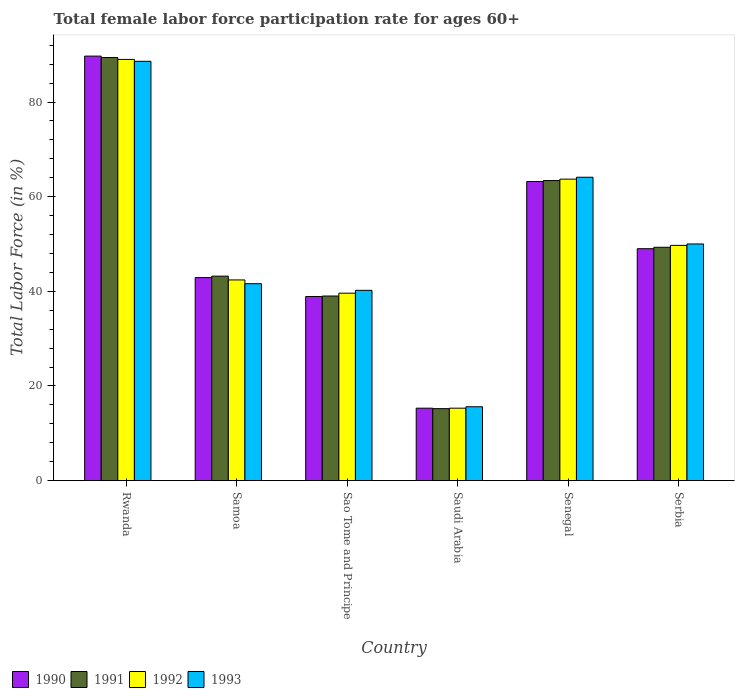Are the number of bars per tick equal to the number of legend labels?
Provide a succinct answer. Yes. Are the number of bars on each tick of the X-axis equal?
Provide a short and direct response. Yes. How many bars are there on the 3rd tick from the right?
Your response must be concise. 4. What is the label of the 6th group of bars from the left?
Your answer should be very brief. Serbia. What is the female labor force participation rate in 1993 in Sao Tome and Principe?
Offer a very short reply. 40.2. Across all countries, what is the maximum female labor force participation rate in 1991?
Ensure brevity in your answer.  89.4. Across all countries, what is the minimum female labor force participation rate in 1993?
Your answer should be very brief. 15.6. In which country was the female labor force participation rate in 1992 maximum?
Give a very brief answer. Rwanda. In which country was the female labor force participation rate in 1991 minimum?
Offer a very short reply. Saudi Arabia. What is the total female labor force participation rate in 1990 in the graph?
Offer a terse response. 299. What is the difference between the female labor force participation rate in 1990 in Sao Tome and Principe and that in Senegal?
Give a very brief answer. -24.3. What is the difference between the female labor force participation rate in 1991 in Saudi Arabia and the female labor force participation rate in 1992 in Serbia?
Provide a short and direct response. -34.5. What is the average female labor force participation rate in 1992 per country?
Provide a short and direct response. 49.95. What is the difference between the female labor force participation rate of/in 1991 and female labor force participation rate of/in 1990 in Sao Tome and Principe?
Your answer should be compact. 0.1. In how many countries, is the female labor force participation rate in 1991 greater than 32 %?
Your answer should be very brief. 5. What is the ratio of the female labor force participation rate in 1990 in Rwanda to that in Samoa?
Keep it short and to the point. 2.09. Is the female labor force participation rate in 1993 in Saudi Arabia less than that in Senegal?
Provide a short and direct response. Yes. Is the difference between the female labor force participation rate in 1991 in Saudi Arabia and Serbia greater than the difference between the female labor force participation rate in 1990 in Saudi Arabia and Serbia?
Your answer should be very brief. No. What is the difference between the highest and the second highest female labor force participation rate in 1992?
Offer a very short reply. 39.3. What is the difference between the highest and the lowest female labor force participation rate in 1990?
Offer a terse response. 74.4. Is the sum of the female labor force participation rate in 1991 in Sao Tome and Principe and Saudi Arabia greater than the maximum female labor force participation rate in 1993 across all countries?
Offer a very short reply. No. What does the 2nd bar from the left in Serbia represents?
Make the answer very short. 1991. Is it the case that in every country, the sum of the female labor force participation rate in 1992 and female labor force participation rate in 1993 is greater than the female labor force participation rate in 1990?
Your answer should be very brief. Yes. What is the difference between two consecutive major ticks on the Y-axis?
Ensure brevity in your answer.  20. Are the values on the major ticks of Y-axis written in scientific E-notation?
Your response must be concise. No. Does the graph contain any zero values?
Keep it short and to the point. No. Where does the legend appear in the graph?
Ensure brevity in your answer.  Bottom left. How many legend labels are there?
Provide a short and direct response. 4. What is the title of the graph?
Offer a very short reply. Total female labor force participation rate for ages 60+. Does "1983" appear as one of the legend labels in the graph?
Ensure brevity in your answer.  No. What is the label or title of the Y-axis?
Offer a terse response. Total Labor Force (in %). What is the Total Labor Force (in %) in 1990 in Rwanda?
Provide a succinct answer. 89.7. What is the Total Labor Force (in %) in 1991 in Rwanda?
Give a very brief answer. 89.4. What is the Total Labor Force (in %) in 1992 in Rwanda?
Give a very brief answer. 89. What is the Total Labor Force (in %) of 1993 in Rwanda?
Your answer should be compact. 88.6. What is the Total Labor Force (in %) in 1990 in Samoa?
Ensure brevity in your answer.  42.9. What is the Total Labor Force (in %) in 1991 in Samoa?
Provide a succinct answer. 43.2. What is the Total Labor Force (in %) of 1992 in Samoa?
Give a very brief answer. 42.4. What is the Total Labor Force (in %) of 1993 in Samoa?
Offer a terse response. 41.6. What is the Total Labor Force (in %) of 1990 in Sao Tome and Principe?
Provide a succinct answer. 38.9. What is the Total Labor Force (in %) of 1991 in Sao Tome and Principe?
Offer a terse response. 39. What is the Total Labor Force (in %) of 1992 in Sao Tome and Principe?
Give a very brief answer. 39.6. What is the Total Labor Force (in %) of 1993 in Sao Tome and Principe?
Give a very brief answer. 40.2. What is the Total Labor Force (in %) of 1990 in Saudi Arabia?
Your answer should be compact. 15.3. What is the Total Labor Force (in %) in 1991 in Saudi Arabia?
Your response must be concise. 15.2. What is the Total Labor Force (in %) of 1992 in Saudi Arabia?
Offer a terse response. 15.3. What is the Total Labor Force (in %) in 1993 in Saudi Arabia?
Offer a terse response. 15.6. What is the Total Labor Force (in %) in 1990 in Senegal?
Your response must be concise. 63.2. What is the Total Labor Force (in %) of 1991 in Senegal?
Ensure brevity in your answer.  63.4. What is the Total Labor Force (in %) in 1992 in Senegal?
Your answer should be very brief. 63.7. What is the Total Labor Force (in %) of 1993 in Senegal?
Your answer should be compact. 64.1. What is the Total Labor Force (in %) of 1990 in Serbia?
Your answer should be compact. 49. What is the Total Labor Force (in %) in 1991 in Serbia?
Give a very brief answer. 49.3. What is the Total Labor Force (in %) of 1992 in Serbia?
Your answer should be very brief. 49.7. Across all countries, what is the maximum Total Labor Force (in %) in 1990?
Offer a very short reply. 89.7. Across all countries, what is the maximum Total Labor Force (in %) in 1991?
Make the answer very short. 89.4. Across all countries, what is the maximum Total Labor Force (in %) of 1992?
Provide a short and direct response. 89. Across all countries, what is the maximum Total Labor Force (in %) of 1993?
Offer a terse response. 88.6. Across all countries, what is the minimum Total Labor Force (in %) of 1990?
Keep it short and to the point. 15.3. Across all countries, what is the minimum Total Labor Force (in %) in 1991?
Offer a very short reply. 15.2. Across all countries, what is the minimum Total Labor Force (in %) of 1992?
Ensure brevity in your answer.  15.3. Across all countries, what is the minimum Total Labor Force (in %) of 1993?
Offer a very short reply. 15.6. What is the total Total Labor Force (in %) of 1990 in the graph?
Make the answer very short. 299. What is the total Total Labor Force (in %) in 1991 in the graph?
Ensure brevity in your answer.  299.5. What is the total Total Labor Force (in %) of 1992 in the graph?
Provide a succinct answer. 299.7. What is the total Total Labor Force (in %) of 1993 in the graph?
Provide a succinct answer. 300.1. What is the difference between the Total Labor Force (in %) in 1990 in Rwanda and that in Samoa?
Provide a succinct answer. 46.8. What is the difference between the Total Labor Force (in %) in 1991 in Rwanda and that in Samoa?
Provide a short and direct response. 46.2. What is the difference between the Total Labor Force (in %) in 1992 in Rwanda and that in Samoa?
Your answer should be very brief. 46.6. What is the difference between the Total Labor Force (in %) in 1990 in Rwanda and that in Sao Tome and Principe?
Provide a short and direct response. 50.8. What is the difference between the Total Labor Force (in %) in 1991 in Rwanda and that in Sao Tome and Principe?
Your answer should be very brief. 50.4. What is the difference between the Total Labor Force (in %) of 1992 in Rwanda and that in Sao Tome and Principe?
Your response must be concise. 49.4. What is the difference between the Total Labor Force (in %) in 1993 in Rwanda and that in Sao Tome and Principe?
Your answer should be compact. 48.4. What is the difference between the Total Labor Force (in %) in 1990 in Rwanda and that in Saudi Arabia?
Provide a short and direct response. 74.4. What is the difference between the Total Labor Force (in %) in 1991 in Rwanda and that in Saudi Arabia?
Offer a very short reply. 74.2. What is the difference between the Total Labor Force (in %) of 1992 in Rwanda and that in Saudi Arabia?
Offer a terse response. 73.7. What is the difference between the Total Labor Force (in %) of 1991 in Rwanda and that in Senegal?
Ensure brevity in your answer.  26. What is the difference between the Total Labor Force (in %) in 1992 in Rwanda and that in Senegal?
Your answer should be compact. 25.3. What is the difference between the Total Labor Force (in %) in 1990 in Rwanda and that in Serbia?
Provide a succinct answer. 40.7. What is the difference between the Total Labor Force (in %) of 1991 in Rwanda and that in Serbia?
Your response must be concise. 40.1. What is the difference between the Total Labor Force (in %) in 1992 in Rwanda and that in Serbia?
Keep it short and to the point. 39.3. What is the difference between the Total Labor Force (in %) in 1993 in Rwanda and that in Serbia?
Provide a succinct answer. 38.6. What is the difference between the Total Labor Force (in %) in 1991 in Samoa and that in Sao Tome and Principe?
Provide a short and direct response. 4.2. What is the difference between the Total Labor Force (in %) of 1990 in Samoa and that in Saudi Arabia?
Provide a short and direct response. 27.6. What is the difference between the Total Labor Force (in %) in 1991 in Samoa and that in Saudi Arabia?
Your answer should be very brief. 28. What is the difference between the Total Labor Force (in %) in 1992 in Samoa and that in Saudi Arabia?
Make the answer very short. 27.1. What is the difference between the Total Labor Force (in %) in 1993 in Samoa and that in Saudi Arabia?
Ensure brevity in your answer.  26. What is the difference between the Total Labor Force (in %) in 1990 in Samoa and that in Senegal?
Make the answer very short. -20.3. What is the difference between the Total Labor Force (in %) of 1991 in Samoa and that in Senegal?
Provide a succinct answer. -20.2. What is the difference between the Total Labor Force (in %) of 1992 in Samoa and that in Senegal?
Your answer should be very brief. -21.3. What is the difference between the Total Labor Force (in %) of 1993 in Samoa and that in Senegal?
Offer a terse response. -22.5. What is the difference between the Total Labor Force (in %) in 1992 in Samoa and that in Serbia?
Provide a short and direct response. -7.3. What is the difference between the Total Labor Force (in %) of 1990 in Sao Tome and Principe and that in Saudi Arabia?
Your answer should be compact. 23.6. What is the difference between the Total Labor Force (in %) of 1991 in Sao Tome and Principe and that in Saudi Arabia?
Give a very brief answer. 23.8. What is the difference between the Total Labor Force (in %) of 1992 in Sao Tome and Principe and that in Saudi Arabia?
Your answer should be compact. 24.3. What is the difference between the Total Labor Force (in %) of 1993 in Sao Tome and Principe and that in Saudi Arabia?
Your answer should be compact. 24.6. What is the difference between the Total Labor Force (in %) in 1990 in Sao Tome and Principe and that in Senegal?
Offer a very short reply. -24.3. What is the difference between the Total Labor Force (in %) in 1991 in Sao Tome and Principe and that in Senegal?
Keep it short and to the point. -24.4. What is the difference between the Total Labor Force (in %) of 1992 in Sao Tome and Principe and that in Senegal?
Provide a succinct answer. -24.1. What is the difference between the Total Labor Force (in %) of 1993 in Sao Tome and Principe and that in Senegal?
Your answer should be compact. -23.9. What is the difference between the Total Labor Force (in %) of 1990 in Sao Tome and Principe and that in Serbia?
Give a very brief answer. -10.1. What is the difference between the Total Labor Force (in %) in 1990 in Saudi Arabia and that in Senegal?
Your answer should be compact. -47.9. What is the difference between the Total Labor Force (in %) in 1991 in Saudi Arabia and that in Senegal?
Offer a terse response. -48.2. What is the difference between the Total Labor Force (in %) in 1992 in Saudi Arabia and that in Senegal?
Your response must be concise. -48.4. What is the difference between the Total Labor Force (in %) in 1993 in Saudi Arabia and that in Senegal?
Ensure brevity in your answer.  -48.5. What is the difference between the Total Labor Force (in %) of 1990 in Saudi Arabia and that in Serbia?
Provide a succinct answer. -33.7. What is the difference between the Total Labor Force (in %) in 1991 in Saudi Arabia and that in Serbia?
Provide a short and direct response. -34.1. What is the difference between the Total Labor Force (in %) of 1992 in Saudi Arabia and that in Serbia?
Your answer should be compact. -34.4. What is the difference between the Total Labor Force (in %) in 1993 in Saudi Arabia and that in Serbia?
Provide a short and direct response. -34.4. What is the difference between the Total Labor Force (in %) in 1992 in Senegal and that in Serbia?
Your answer should be compact. 14. What is the difference between the Total Labor Force (in %) in 1990 in Rwanda and the Total Labor Force (in %) in 1991 in Samoa?
Give a very brief answer. 46.5. What is the difference between the Total Labor Force (in %) of 1990 in Rwanda and the Total Labor Force (in %) of 1992 in Samoa?
Ensure brevity in your answer.  47.3. What is the difference between the Total Labor Force (in %) in 1990 in Rwanda and the Total Labor Force (in %) in 1993 in Samoa?
Your answer should be compact. 48.1. What is the difference between the Total Labor Force (in %) of 1991 in Rwanda and the Total Labor Force (in %) of 1993 in Samoa?
Keep it short and to the point. 47.8. What is the difference between the Total Labor Force (in %) of 1992 in Rwanda and the Total Labor Force (in %) of 1993 in Samoa?
Your response must be concise. 47.4. What is the difference between the Total Labor Force (in %) of 1990 in Rwanda and the Total Labor Force (in %) of 1991 in Sao Tome and Principe?
Your answer should be very brief. 50.7. What is the difference between the Total Labor Force (in %) of 1990 in Rwanda and the Total Labor Force (in %) of 1992 in Sao Tome and Principe?
Offer a terse response. 50.1. What is the difference between the Total Labor Force (in %) of 1990 in Rwanda and the Total Labor Force (in %) of 1993 in Sao Tome and Principe?
Provide a succinct answer. 49.5. What is the difference between the Total Labor Force (in %) of 1991 in Rwanda and the Total Labor Force (in %) of 1992 in Sao Tome and Principe?
Offer a very short reply. 49.8. What is the difference between the Total Labor Force (in %) in 1991 in Rwanda and the Total Labor Force (in %) in 1993 in Sao Tome and Principe?
Your answer should be compact. 49.2. What is the difference between the Total Labor Force (in %) of 1992 in Rwanda and the Total Labor Force (in %) of 1993 in Sao Tome and Principe?
Keep it short and to the point. 48.8. What is the difference between the Total Labor Force (in %) in 1990 in Rwanda and the Total Labor Force (in %) in 1991 in Saudi Arabia?
Give a very brief answer. 74.5. What is the difference between the Total Labor Force (in %) in 1990 in Rwanda and the Total Labor Force (in %) in 1992 in Saudi Arabia?
Offer a very short reply. 74.4. What is the difference between the Total Labor Force (in %) of 1990 in Rwanda and the Total Labor Force (in %) of 1993 in Saudi Arabia?
Your answer should be compact. 74.1. What is the difference between the Total Labor Force (in %) of 1991 in Rwanda and the Total Labor Force (in %) of 1992 in Saudi Arabia?
Offer a terse response. 74.1. What is the difference between the Total Labor Force (in %) of 1991 in Rwanda and the Total Labor Force (in %) of 1993 in Saudi Arabia?
Offer a terse response. 73.8. What is the difference between the Total Labor Force (in %) of 1992 in Rwanda and the Total Labor Force (in %) of 1993 in Saudi Arabia?
Your answer should be compact. 73.4. What is the difference between the Total Labor Force (in %) of 1990 in Rwanda and the Total Labor Force (in %) of 1991 in Senegal?
Offer a very short reply. 26.3. What is the difference between the Total Labor Force (in %) in 1990 in Rwanda and the Total Labor Force (in %) in 1992 in Senegal?
Give a very brief answer. 26. What is the difference between the Total Labor Force (in %) in 1990 in Rwanda and the Total Labor Force (in %) in 1993 in Senegal?
Give a very brief answer. 25.6. What is the difference between the Total Labor Force (in %) in 1991 in Rwanda and the Total Labor Force (in %) in 1992 in Senegal?
Make the answer very short. 25.7. What is the difference between the Total Labor Force (in %) of 1991 in Rwanda and the Total Labor Force (in %) of 1993 in Senegal?
Offer a very short reply. 25.3. What is the difference between the Total Labor Force (in %) of 1992 in Rwanda and the Total Labor Force (in %) of 1993 in Senegal?
Keep it short and to the point. 24.9. What is the difference between the Total Labor Force (in %) of 1990 in Rwanda and the Total Labor Force (in %) of 1991 in Serbia?
Offer a very short reply. 40.4. What is the difference between the Total Labor Force (in %) in 1990 in Rwanda and the Total Labor Force (in %) in 1992 in Serbia?
Offer a terse response. 40. What is the difference between the Total Labor Force (in %) of 1990 in Rwanda and the Total Labor Force (in %) of 1993 in Serbia?
Keep it short and to the point. 39.7. What is the difference between the Total Labor Force (in %) in 1991 in Rwanda and the Total Labor Force (in %) in 1992 in Serbia?
Keep it short and to the point. 39.7. What is the difference between the Total Labor Force (in %) in 1991 in Rwanda and the Total Labor Force (in %) in 1993 in Serbia?
Provide a succinct answer. 39.4. What is the difference between the Total Labor Force (in %) in 1992 in Rwanda and the Total Labor Force (in %) in 1993 in Serbia?
Your answer should be compact. 39. What is the difference between the Total Labor Force (in %) of 1990 in Samoa and the Total Labor Force (in %) of 1991 in Sao Tome and Principe?
Ensure brevity in your answer.  3.9. What is the difference between the Total Labor Force (in %) of 1990 in Samoa and the Total Labor Force (in %) of 1992 in Sao Tome and Principe?
Ensure brevity in your answer.  3.3. What is the difference between the Total Labor Force (in %) in 1991 in Samoa and the Total Labor Force (in %) in 1992 in Sao Tome and Principe?
Give a very brief answer. 3.6. What is the difference between the Total Labor Force (in %) of 1991 in Samoa and the Total Labor Force (in %) of 1993 in Sao Tome and Principe?
Ensure brevity in your answer.  3. What is the difference between the Total Labor Force (in %) in 1990 in Samoa and the Total Labor Force (in %) in 1991 in Saudi Arabia?
Provide a succinct answer. 27.7. What is the difference between the Total Labor Force (in %) of 1990 in Samoa and the Total Labor Force (in %) of 1992 in Saudi Arabia?
Make the answer very short. 27.6. What is the difference between the Total Labor Force (in %) in 1990 in Samoa and the Total Labor Force (in %) in 1993 in Saudi Arabia?
Make the answer very short. 27.3. What is the difference between the Total Labor Force (in %) in 1991 in Samoa and the Total Labor Force (in %) in 1992 in Saudi Arabia?
Offer a terse response. 27.9. What is the difference between the Total Labor Force (in %) in 1991 in Samoa and the Total Labor Force (in %) in 1993 in Saudi Arabia?
Offer a terse response. 27.6. What is the difference between the Total Labor Force (in %) of 1992 in Samoa and the Total Labor Force (in %) of 1993 in Saudi Arabia?
Offer a terse response. 26.8. What is the difference between the Total Labor Force (in %) in 1990 in Samoa and the Total Labor Force (in %) in 1991 in Senegal?
Make the answer very short. -20.5. What is the difference between the Total Labor Force (in %) of 1990 in Samoa and the Total Labor Force (in %) of 1992 in Senegal?
Your answer should be compact. -20.8. What is the difference between the Total Labor Force (in %) in 1990 in Samoa and the Total Labor Force (in %) in 1993 in Senegal?
Provide a succinct answer. -21.2. What is the difference between the Total Labor Force (in %) in 1991 in Samoa and the Total Labor Force (in %) in 1992 in Senegal?
Your response must be concise. -20.5. What is the difference between the Total Labor Force (in %) of 1991 in Samoa and the Total Labor Force (in %) of 1993 in Senegal?
Offer a very short reply. -20.9. What is the difference between the Total Labor Force (in %) of 1992 in Samoa and the Total Labor Force (in %) of 1993 in Senegal?
Give a very brief answer. -21.7. What is the difference between the Total Labor Force (in %) in 1990 in Samoa and the Total Labor Force (in %) in 1991 in Serbia?
Your answer should be compact. -6.4. What is the difference between the Total Labor Force (in %) of 1990 in Samoa and the Total Labor Force (in %) of 1992 in Serbia?
Your response must be concise. -6.8. What is the difference between the Total Labor Force (in %) in 1990 in Samoa and the Total Labor Force (in %) in 1993 in Serbia?
Provide a succinct answer. -7.1. What is the difference between the Total Labor Force (in %) of 1990 in Sao Tome and Principe and the Total Labor Force (in %) of 1991 in Saudi Arabia?
Your answer should be compact. 23.7. What is the difference between the Total Labor Force (in %) of 1990 in Sao Tome and Principe and the Total Labor Force (in %) of 1992 in Saudi Arabia?
Offer a terse response. 23.6. What is the difference between the Total Labor Force (in %) of 1990 in Sao Tome and Principe and the Total Labor Force (in %) of 1993 in Saudi Arabia?
Provide a short and direct response. 23.3. What is the difference between the Total Labor Force (in %) of 1991 in Sao Tome and Principe and the Total Labor Force (in %) of 1992 in Saudi Arabia?
Give a very brief answer. 23.7. What is the difference between the Total Labor Force (in %) of 1991 in Sao Tome and Principe and the Total Labor Force (in %) of 1993 in Saudi Arabia?
Offer a terse response. 23.4. What is the difference between the Total Labor Force (in %) of 1990 in Sao Tome and Principe and the Total Labor Force (in %) of 1991 in Senegal?
Keep it short and to the point. -24.5. What is the difference between the Total Labor Force (in %) of 1990 in Sao Tome and Principe and the Total Labor Force (in %) of 1992 in Senegal?
Provide a short and direct response. -24.8. What is the difference between the Total Labor Force (in %) in 1990 in Sao Tome and Principe and the Total Labor Force (in %) in 1993 in Senegal?
Provide a succinct answer. -25.2. What is the difference between the Total Labor Force (in %) of 1991 in Sao Tome and Principe and the Total Labor Force (in %) of 1992 in Senegal?
Your response must be concise. -24.7. What is the difference between the Total Labor Force (in %) of 1991 in Sao Tome and Principe and the Total Labor Force (in %) of 1993 in Senegal?
Provide a short and direct response. -25.1. What is the difference between the Total Labor Force (in %) in 1992 in Sao Tome and Principe and the Total Labor Force (in %) in 1993 in Senegal?
Offer a very short reply. -24.5. What is the difference between the Total Labor Force (in %) of 1990 in Sao Tome and Principe and the Total Labor Force (in %) of 1991 in Serbia?
Give a very brief answer. -10.4. What is the difference between the Total Labor Force (in %) of 1990 in Sao Tome and Principe and the Total Labor Force (in %) of 1992 in Serbia?
Ensure brevity in your answer.  -10.8. What is the difference between the Total Labor Force (in %) of 1990 in Sao Tome and Principe and the Total Labor Force (in %) of 1993 in Serbia?
Offer a terse response. -11.1. What is the difference between the Total Labor Force (in %) of 1991 in Sao Tome and Principe and the Total Labor Force (in %) of 1993 in Serbia?
Offer a very short reply. -11. What is the difference between the Total Labor Force (in %) of 1992 in Sao Tome and Principe and the Total Labor Force (in %) of 1993 in Serbia?
Ensure brevity in your answer.  -10.4. What is the difference between the Total Labor Force (in %) of 1990 in Saudi Arabia and the Total Labor Force (in %) of 1991 in Senegal?
Your response must be concise. -48.1. What is the difference between the Total Labor Force (in %) in 1990 in Saudi Arabia and the Total Labor Force (in %) in 1992 in Senegal?
Offer a terse response. -48.4. What is the difference between the Total Labor Force (in %) of 1990 in Saudi Arabia and the Total Labor Force (in %) of 1993 in Senegal?
Your answer should be very brief. -48.8. What is the difference between the Total Labor Force (in %) in 1991 in Saudi Arabia and the Total Labor Force (in %) in 1992 in Senegal?
Provide a succinct answer. -48.5. What is the difference between the Total Labor Force (in %) of 1991 in Saudi Arabia and the Total Labor Force (in %) of 1993 in Senegal?
Your answer should be very brief. -48.9. What is the difference between the Total Labor Force (in %) in 1992 in Saudi Arabia and the Total Labor Force (in %) in 1993 in Senegal?
Offer a terse response. -48.8. What is the difference between the Total Labor Force (in %) of 1990 in Saudi Arabia and the Total Labor Force (in %) of 1991 in Serbia?
Keep it short and to the point. -34. What is the difference between the Total Labor Force (in %) of 1990 in Saudi Arabia and the Total Labor Force (in %) of 1992 in Serbia?
Your answer should be very brief. -34.4. What is the difference between the Total Labor Force (in %) of 1990 in Saudi Arabia and the Total Labor Force (in %) of 1993 in Serbia?
Your response must be concise. -34.7. What is the difference between the Total Labor Force (in %) in 1991 in Saudi Arabia and the Total Labor Force (in %) in 1992 in Serbia?
Give a very brief answer. -34.5. What is the difference between the Total Labor Force (in %) of 1991 in Saudi Arabia and the Total Labor Force (in %) of 1993 in Serbia?
Give a very brief answer. -34.8. What is the difference between the Total Labor Force (in %) of 1992 in Saudi Arabia and the Total Labor Force (in %) of 1993 in Serbia?
Make the answer very short. -34.7. What is the difference between the Total Labor Force (in %) in 1990 in Senegal and the Total Labor Force (in %) in 1991 in Serbia?
Offer a very short reply. 13.9. What is the difference between the Total Labor Force (in %) of 1991 in Senegal and the Total Labor Force (in %) of 1993 in Serbia?
Offer a terse response. 13.4. What is the difference between the Total Labor Force (in %) of 1992 in Senegal and the Total Labor Force (in %) of 1993 in Serbia?
Provide a succinct answer. 13.7. What is the average Total Labor Force (in %) of 1990 per country?
Offer a very short reply. 49.83. What is the average Total Labor Force (in %) in 1991 per country?
Offer a very short reply. 49.92. What is the average Total Labor Force (in %) of 1992 per country?
Provide a short and direct response. 49.95. What is the average Total Labor Force (in %) in 1993 per country?
Ensure brevity in your answer.  50.02. What is the difference between the Total Labor Force (in %) of 1990 and Total Labor Force (in %) of 1992 in Rwanda?
Offer a very short reply. 0.7. What is the difference between the Total Labor Force (in %) in 1991 and Total Labor Force (in %) in 1992 in Rwanda?
Make the answer very short. 0.4. What is the difference between the Total Labor Force (in %) of 1991 and Total Labor Force (in %) of 1993 in Rwanda?
Provide a short and direct response. 0.8. What is the difference between the Total Labor Force (in %) in 1990 and Total Labor Force (in %) in 1991 in Samoa?
Provide a short and direct response. -0.3. What is the difference between the Total Labor Force (in %) in 1990 and Total Labor Force (in %) in 1992 in Samoa?
Your response must be concise. 0.5. What is the difference between the Total Labor Force (in %) of 1990 and Total Labor Force (in %) of 1993 in Samoa?
Your response must be concise. 1.3. What is the difference between the Total Labor Force (in %) of 1991 and Total Labor Force (in %) of 1992 in Samoa?
Your response must be concise. 0.8. What is the difference between the Total Labor Force (in %) of 1991 and Total Labor Force (in %) of 1993 in Samoa?
Your answer should be very brief. 1.6. What is the difference between the Total Labor Force (in %) of 1990 and Total Labor Force (in %) of 1991 in Sao Tome and Principe?
Provide a short and direct response. -0.1. What is the difference between the Total Labor Force (in %) in 1990 and Total Labor Force (in %) in 1992 in Sao Tome and Principe?
Provide a succinct answer. -0.7. What is the difference between the Total Labor Force (in %) in 1991 and Total Labor Force (in %) in 1992 in Sao Tome and Principe?
Give a very brief answer. -0.6. What is the difference between the Total Labor Force (in %) of 1991 and Total Labor Force (in %) of 1993 in Sao Tome and Principe?
Your answer should be compact. -1.2. What is the difference between the Total Labor Force (in %) in 1992 and Total Labor Force (in %) in 1993 in Sao Tome and Principe?
Provide a succinct answer. -0.6. What is the difference between the Total Labor Force (in %) in 1990 and Total Labor Force (in %) in 1991 in Saudi Arabia?
Your answer should be very brief. 0.1. What is the difference between the Total Labor Force (in %) in 1990 and Total Labor Force (in %) in 1992 in Saudi Arabia?
Offer a terse response. 0. What is the difference between the Total Labor Force (in %) of 1990 and Total Labor Force (in %) of 1993 in Saudi Arabia?
Your response must be concise. -0.3. What is the difference between the Total Labor Force (in %) in 1990 and Total Labor Force (in %) in 1992 in Senegal?
Make the answer very short. -0.5. What is the difference between the Total Labor Force (in %) in 1990 and Total Labor Force (in %) in 1993 in Senegal?
Keep it short and to the point. -0.9. What is the difference between the Total Labor Force (in %) in 1991 and Total Labor Force (in %) in 1992 in Senegal?
Provide a succinct answer. -0.3. What is the difference between the Total Labor Force (in %) in 1990 and Total Labor Force (in %) in 1991 in Serbia?
Your answer should be very brief. -0.3. What is the difference between the Total Labor Force (in %) of 1990 and Total Labor Force (in %) of 1992 in Serbia?
Your response must be concise. -0.7. What is the difference between the Total Labor Force (in %) of 1990 and Total Labor Force (in %) of 1993 in Serbia?
Your answer should be compact. -1. What is the difference between the Total Labor Force (in %) of 1991 and Total Labor Force (in %) of 1992 in Serbia?
Give a very brief answer. -0.4. What is the difference between the Total Labor Force (in %) in 1991 and Total Labor Force (in %) in 1993 in Serbia?
Provide a succinct answer. -0.7. What is the ratio of the Total Labor Force (in %) of 1990 in Rwanda to that in Samoa?
Provide a short and direct response. 2.09. What is the ratio of the Total Labor Force (in %) in 1991 in Rwanda to that in Samoa?
Give a very brief answer. 2.07. What is the ratio of the Total Labor Force (in %) in 1992 in Rwanda to that in Samoa?
Keep it short and to the point. 2.1. What is the ratio of the Total Labor Force (in %) in 1993 in Rwanda to that in Samoa?
Provide a succinct answer. 2.13. What is the ratio of the Total Labor Force (in %) of 1990 in Rwanda to that in Sao Tome and Principe?
Keep it short and to the point. 2.31. What is the ratio of the Total Labor Force (in %) in 1991 in Rwanda to that in Sao Tome and Principe?
Your response must be concise. 2.29. What is the ratio of the Total Labor Force (in %) of 1992 in Rwanda to that in Sao Tome and Principe?
Offer a very short reply. 2.25. What is the ratio of the Total Labor Force (in %) in 1993 in Rwanda to that in Sao Tome and Principe?
Your answer should be compact. 2.2. What is the ratio of the Total Labor Force (in %) in 1990 in Rwanda to that in Saudi Arabia?
Make the answer very short. 5.86. What is the ratio of the Total Labor Force (in %) in 1991 in Rwanda to that in Saudi Arabia?
Keep it short and to the point. 5.88. What is the ratio of the Total Labor Force (in %) in 1992 in Rwanda to that in Saudi Arabia?
Make the answer very short. 5.82. What is the ratio of the Total Labor Force (in %) in 1993 in Rwanda to that in Saudi Arabia?
Provide a succinct answer. 5.68. What is the ratio of the Total Labor Force (in %) in 1990 in Rwanda to that in Senegal?
Your answer should be very brief. 1.42. What is the ratio of the Total Labor Force (in %) in 1991 in Rwanda to that in Senegal?
Your answer should be very brief. 1.41. What is the ratio of the Total Labor Force (in %) of 1992 in Rwanda to that in Senegal?
Make the answer very short. 1.4. What is the ratio of the Total Labor Force (in %) in 1993 in Rwanda to that in Senegal?
Your answer should be compact. 1.38. What is the ratio of the Total Labor Force (in %) in 1990 in Rwanda to that in Serbia?
Offer a very short reply. 1.83. What is the ratio of the Total Labor Force (in %) of 1991 in Rwanda to that in Serbia?
Provide a succinct answer. 1.81. What is the ratio of the Total Labor Force (in %) of 1992 in Rwanda to that in Serbia?
Offer a terse response. 1.79. What is the ratio of the Total Labor Force (in %) of 1993 in Rwanda to that in Serbia?
Your answer should be very brief. 1.77. What is the ratio of the Total Labor Force (in %) of 1990 in Samoa to that in Sao Tome and Principe?
Ensure brevity in your answer.  1.1. What is the ratio of the Total Labor Force (in %) of 1991 in Samoa to that in Sao Tome and Principe?
Provide a short and direct response. 1.11. What is the ratio of the Total Labor Force (in %) in 1992 in Samoa to that in Sao Tome and Principe?
Keep it short and to the point. 1.07. What is the ratio of the Total Labor Force (in %) of 1993 in Samoa to that in Sao Tome and Principe?
Make the answer very short. 1.03. What is the ratio of the Total Labor Force (in %) of 1990 in Samoa to that in Saudi Arabia?
Offer a terse response. 2.8. What is the ratio of the Total Labor Force (in %) in 1991 in Samoa to that in Saudi Arabia?
Your answer should be compact. 2.84. What is the ratio of the Total Labor Force (in %) in 1992 in Samoa to that in Saudi Arabia?
Your answer should be very brief. 2.77. What is the ratio of the Total Labor Force (in %) in 1993 in Samoa to that in Saudi Arabia?
Make the answer very short. 2.67. What is the ratio of the Total Labor Force (in %) of 1990 in Samoa to that in Senegal?
Keep it short and to the point. 0.68. What is the ratio of the Total Labor Force (in %) of 1991 in Samoa to that in Senegal?
Offer a terse response. 0.68. What is the ratio of the Total Labor Force (in %) in 1992 in Samoa to that in Senegal?
Offer a terse response. 0.67. What is the ratio of the Total Labor Force (in %) in 1993 in Samoa to that in Senegal?
Keep it short and to the point. 0.65. What is the ratio of the Total Labor Force (in %) of 1990 in Samoa to that in Serbia?
Make the answer very short. 0.88. What is the ratio of the Total Labor Force (in %) in 1991 in Samoa to that in Serbia?
Provide a succinct answer. 0.88. What is the ratio of the Total Labor Force (in %) in 1992 in Samoa to that in Serbia?
Ensure brevity in your answer.  0.85. What is the ratio of the Total Labor Force (in %) in 1993 in Samoa to that in Serbia?
Make the answer very short. 0.83. What is the ratio of the Total Labor Force (in %) of 1990 in Sao Tome and Principe to that in Saudi Arabia?
Your answer should be very brief. 2.54. What is the ratio of the Total Labor Force (in %) of 1991 in Sao Tome and Principe to that in Saudi Arabia?
Your answer should be very brief. 2.57. What is the ratio of the Total Labor Force (in %) in 1992 in Sao Tome and Principe to that in Saudi Arabia?
Your response must be concise. 2.59. What is the ratio of the Total Labor Force (in %) in 1993 in Sao Tome and Principe to that in Saudi Arabia?
Your answer should be compact. 2.58. What is the ratio of the Total Labor Force (in %) of 1990 in Sao Tome and Principe to that in Senegal?
Offer a terse response. 0.62. What is the ratio of the Total Labor Force (in %) of 1991 in Sao Tome and Principe to that in Senegal?
Offer a terse response. 0.62. What is the ratio of the Total Labor Force (in %) in 1992 in Sao Tome and Principe to that in Senegal?
Offer a terse response. 0.62. What is the ratio of the Total Labor Force (in %) of 1993 in Sao Tome and Principe to that in Senegal?
Ensure brevity in your answer.  0.63. What is the ratio of the Total Labor Force (in %) in 1990 in Sao Tome and Principe to that in Serbia?
Make the answer very short. 0.79. What is the ratio of the Total Labor Force (in %) of 1991 in Sao Tome and Principe to that in Serbia?
Your answer should be compact. 0.79. What is the ratio of the Total Labor Force (in %) in 1992 in Sao Tome and Principe to that in Serbia?
Your answer should be very brief. 0.8. What is the ratio of the Total Labor Force (in %) in 1993 in Sao Tome and Principe to that in Serbia?
Your response must be concise. 0.8. What is the ratio of the Total Labor Force (in %) of 1990 in Saudi Arabia to that in Senegal?
Ensure brevity in your answer.  0.24. What is the ratio of the Total Labor Force (in %) of 1991 in Saudi Arabia to that in Senegal?
Make the answer very short. 0.24. What is the ratio of the Total Labor Force (in %) in 1992 in Saudi Arabia to that in Senegal?
Your response must be concise. 0.24. What is the ratio of the Total Labor Force (in %) in 1993 in Saudi Arabia to that in Senegal?
Provide a short and direct response. 0.24. What is the ratio of the Total Labor Force (in %) of 1990 in Saudi Arabia to that in Serbia?
Your response must be concise. 0.31. What is the ratio of the Total Labor Force (in %) in 1991 in Saudi Arabia to that in Serbia?
Your answer should be compact. 0.31. What is the ratio of the Total Labor Force (in %) in 1992 in Saudi Arabia to that in Serbia?
Keep it short and to the point. 0.31. What is the ratio of the Total Labor Force (in %) of 1993 in Saudi Arabia to that in Serbia?
Your answer should be very brief. 0.31. What is the ratio of the Total Labor Force (in %) of 1990 in Senegal to that in Serbia?
Provide a succinct answer. 1.29. What is the ratio of the Total Labor Force (in %) of 1991 in Senegal to that in Serbia?
Your response must be concise. 1.29. What is the ratio of the Total Labor Force (in %) of 1992 in Senegal to that in Serbia?
Make the answer very short. 1.28. What is the ratio of the Total Labor Force (in %) in 1993 in Senegal to that in Serbia?
Your answer should be very brief. 1.28. What is the difference between the highest and the second highest Total Labor Force (in %) of 1991?
Make the answer very short. 26. What is the difference between the highest and the second highest Total Labor Force (in %) of 1992?
Offer a very short reply. 25.3. What is the difference between the highest and the lowest Total Labor Force (in %) in 1990?
Your answer should be very brief. 74.4. What is the difference between the highest and the lowest Total Labor Force (in %) of 1991?
Keep it short and to the point. 74.2. What is the difference between the highest and the lowest Total Labor Force (in %) of 1992?
Your answer should be very brief. 73.7. What is the difference between the highest and the lowest Total Labor Force (in %) in 1993?
Your answer should be very brief. 73. 